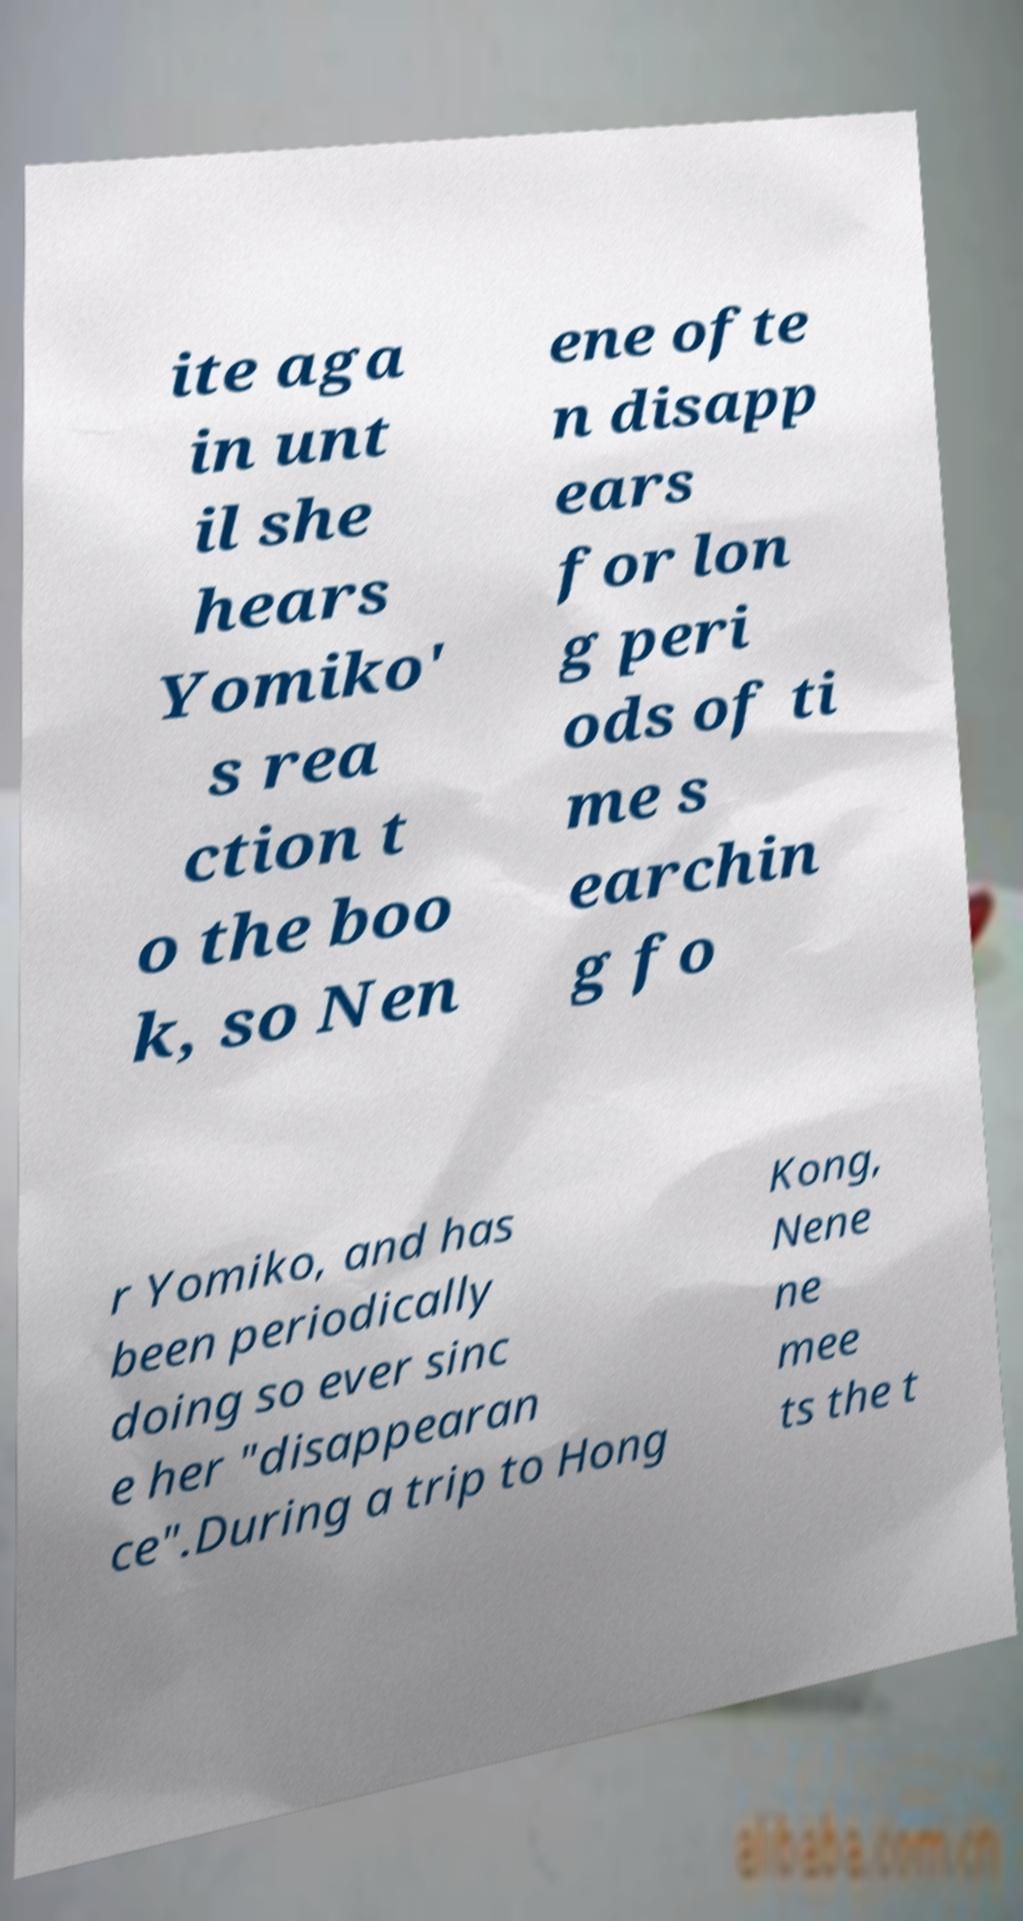Can you accurately transcribe the text from the provided image for me? ite aga in unt il she hears Yomiko' s rea ction t o the boo k, so Nen ene ofte n disapp ears for lon g peri ods of ti me s earchin g fo r Yomiko, and has been periodically doing so ever sinc e her "disappearan ce".During a trip to Hong Kong, Nene ne mee ts the t 